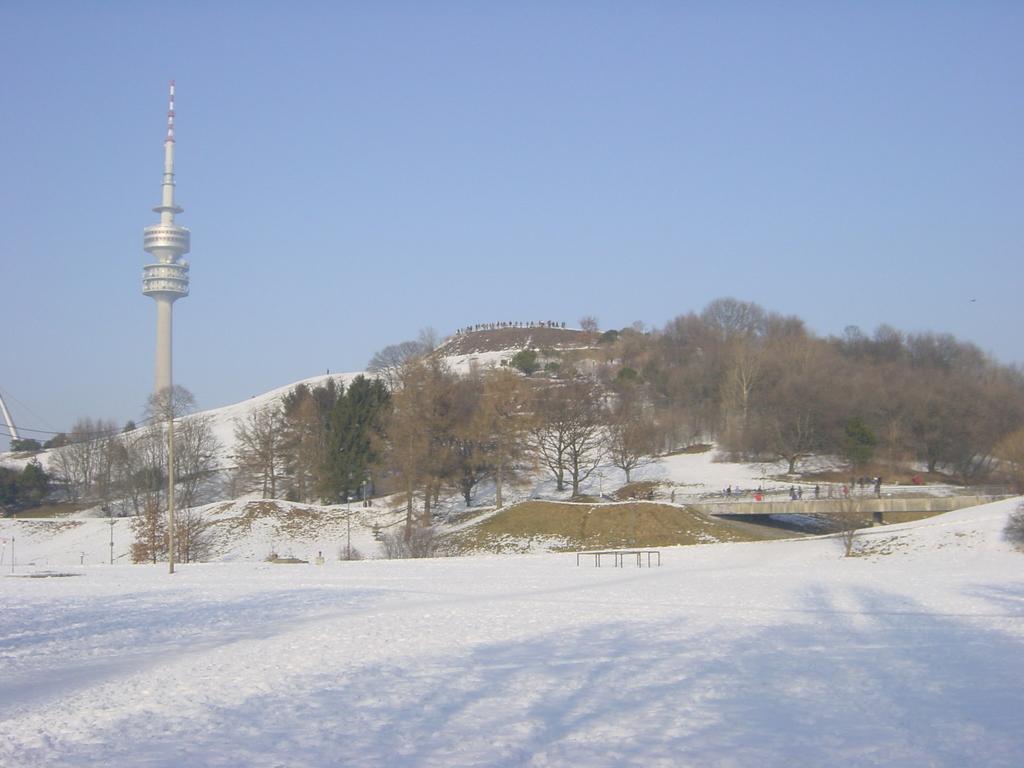Can you describe this image briefly? This is the picture of hill. On the right side of the image there are group of people walking on the bridge. On the left side of the image there is a tower. There are trees on the hill. At the top there is sky. At the bottom there is snow. 